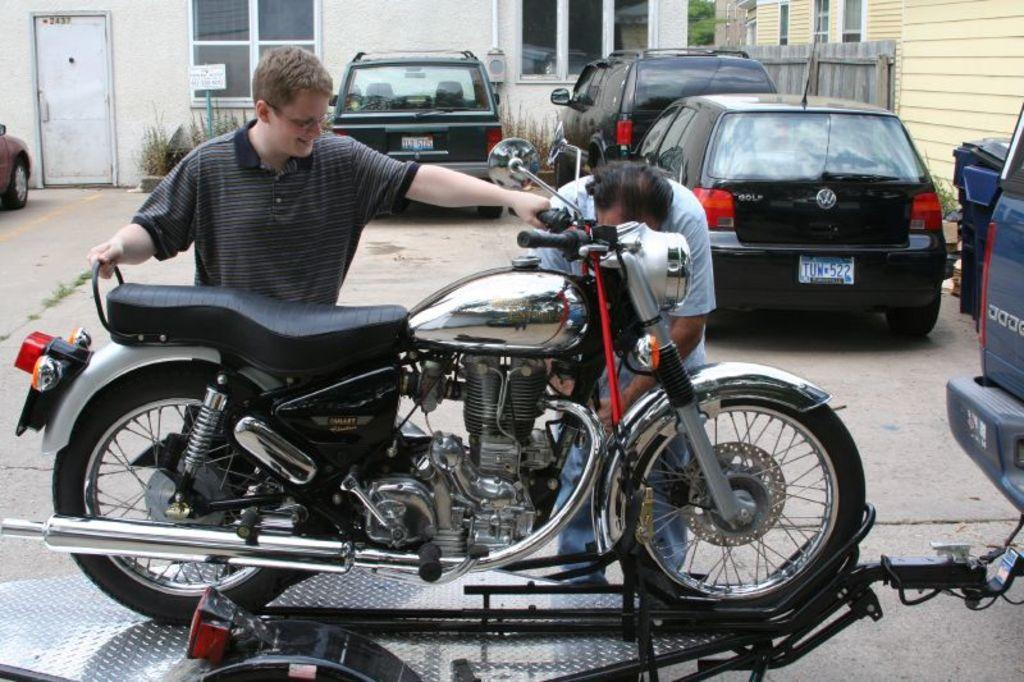How many people are in the image? There are two persons standing beside a bike in the image. What else can be seen in the image besides the people and the bike? There are cars in the image. What can be seen in the background of the image? There are buildings, windows, a door, and plants visible in the background. What type of orange is being used to calculate profit in the image? There is no orange or mention of profit in the image; it features two persons standing beside a bike, cars, and various background elements. 